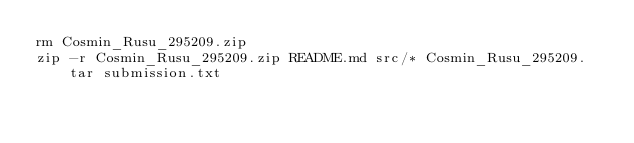<code> <loc_0><loc_0><loc_500><loc_500><_Bash_>rm Cosmin_Rusu_295209.zip
zip -r Cosmin_Rusu_295209.zip README.md src/* Cosmin_Rusu_295209.tar submission.txt
</code> 